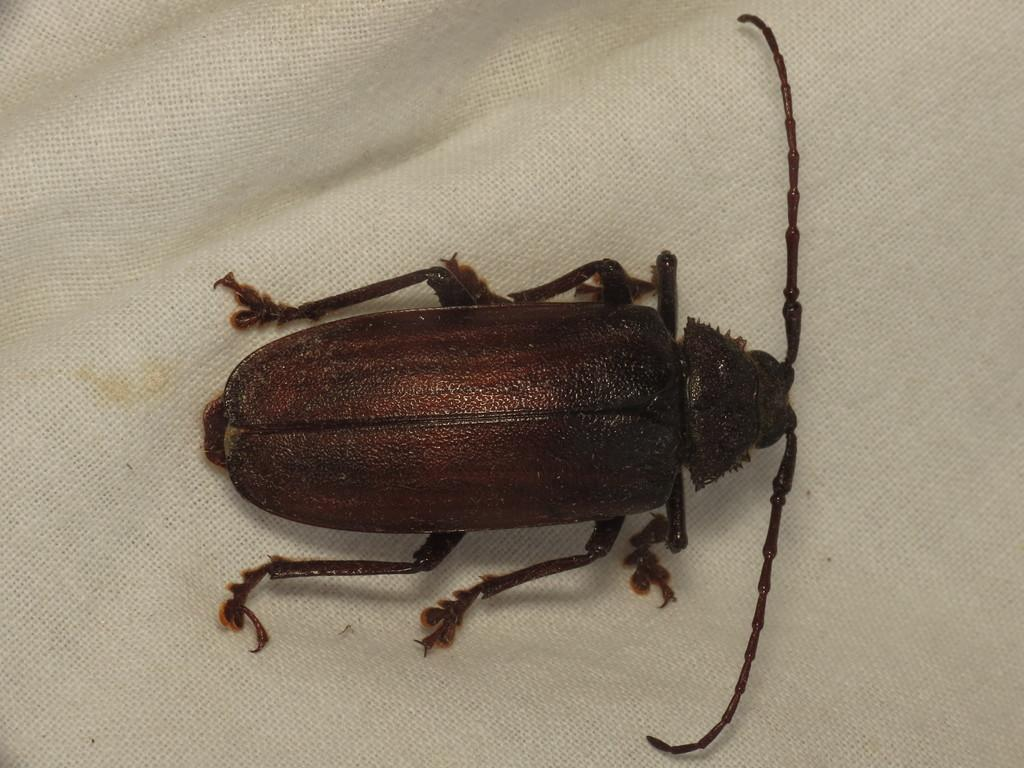What is the main subject of the image? The main subject of the image is a cockroach. Where is the cockroach located in the image? The cockroach is on a white cloth. What type of treatment is the cockroach receiving in the image? There is no indication in the image that the cockroach is receiving any treatment. What type of harmony is depicted in the image? The image does not depict any harmony; it features a cockroach on a white cloth. 